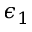Convert formula to latex. <formula><loc_0><loc_0><loc_500><loc_500>\epsilon _ { 1 }</formula> 